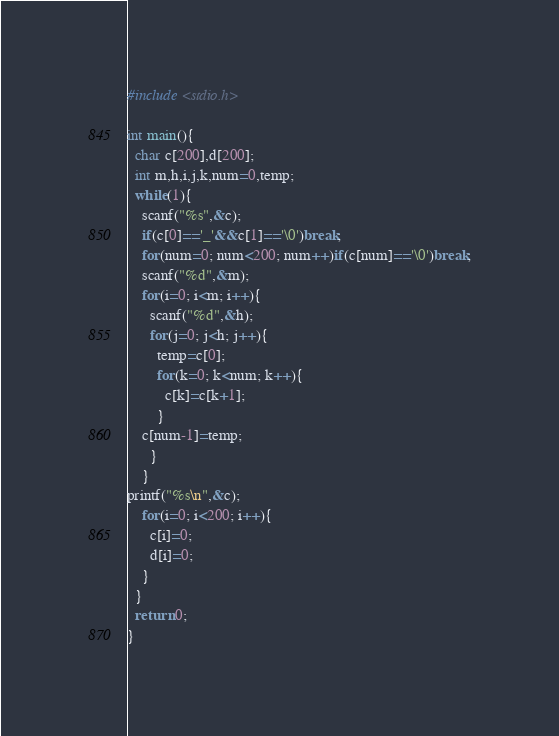Convert code to text. <code><loc_0><loc_0><loc_500><loc_500><_C_>#include <stdio.h>

int main(){
  char c[200],d[200];
  int m,h,i,j,k,num=0,temp;
  while(1){
    scanf("%s",&c);
    if(c[0]=='_'&&c[1]=='\0')break;
    for(num=0; num<200; num++)if(c[num]=='\0')break;
    scanf("%d",&m);
    for(i=0; i<m; i++){
      scanf("%d",&h);
      for(j=0; j<h; j++){
        temp=c[0];
        for(k=0; k<num; k++){
          c[k]=c[k+1];
        }
	c[num-1]=temp;
      }
    }
printf("%s\n",&c);
    for(i=0; i<200; i++){
      c[i]=0;
      d[i]=0;
    }
  }
  return 0;
}</code> 